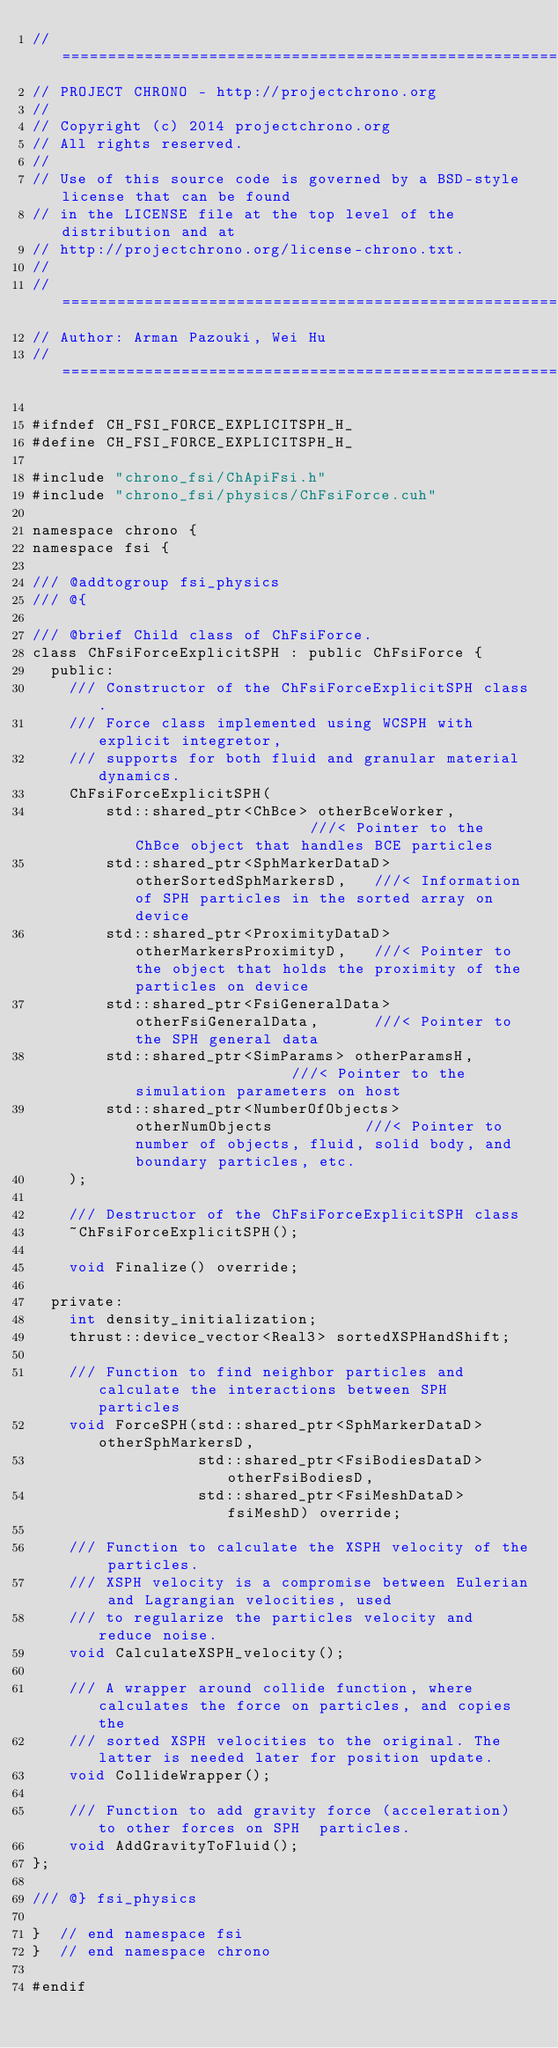<code> <loc_0><loc_0><loc_500><loc_500><_Cuda_>// =============================================================================
// PROJECT CHRONO - http://projectchrono.org
//
// Copyright (c) 2014 projectchrono.org
// All rights reserved.
//
// Use of this source code is governed by a BSD-style license that can be found
// in the LICENSE file at the top level of the distribution and at
// http://projectchrono.org/license-chrono.txt.
//
// =============================================================================
// Author: Arman Pazouki, Wei Hu
// =============================================================================

#ifndef CH_FSI_FORCE_EXPLICITSPH_H_
#define CH_FSI_FORCE_EXPLICITSPH_H_

#include "chrono_fsi/ChApiFsi.h"
#include "chrono_fsi/physics/ChFsiForce.cuh"

namespace chrono {
namespace fsi {

/// @addtogroup fsi_physics
/// @{

/// @brief Child class of ChFsiForce.
class ChFsiForceExplicitSPH : public ChFsiForce {
  public:
    /// Constructor of the ChFsiForceExplicitSPH class.
    /// Force class implemented using WCSPH with explicit integretor,
    /// supports for both fluid and granular material dynamics.
    ChFsiForceExplicitSPH(
        std::shared_ptr<ChBce> otherBceWorker,                    ///< Pointer to the ChBce object that handles BCE particles
        std::shared_ptr<SphMarkerDataD> otherSortedSphMarkersD,   ///< Information of SPH particles in the sorted array on device
        std::shared_ptr<ProximityDataD> otherMarkersProximityD,   ///< Pointer to the object that holds the proximity of the particles on device
        std::shared_ptr<FsiGeneralData> otherFsiGeneralData,      ///< Pointer to the SPH general data
        std::shared_ptr<SimParams> otherParamsH,                  ///< Pointer to the simulation parameters on host
        std::shared_ptr<NumberOfObjects> otherNumObjects          ///< Pointer to number of objects, fluid, solid body, and boundary particles, etc.
    );

    /// Destructor of the ChFsiForceExplicitSPH class
    ~ChFsiForceExplicitSPH();

    void Finalize() override;

  private:
    int density_initialization;
    thrust::device_vector<Real3> sortedXSPHandShift;

    /// Function to find neighbor particles and calculate the interactions between SPH particles
    void ForceSPH(std::shared_ptr<SphMarkerDataD> otherSphMarkersD,
                  std::shared_ptr<FsiBodiesDataD> otherFsiBodiesD,
                  std::shared_ptr<FsiMeshDataD> fsiMeshD) override;
    
    /// Function to calculate the XSPH velocity of the particles.
    /// XSPH velocity is a compromise between Eulerian and Lagrangian velocities, used
    /// to regularize the particles velocity and reduce noise.
    void CalculateXSPH_velocity();

    /// A wrapper around collide function, where calculates the force on particles, and copies the
    /// sorted XSPH velocities to the original. The latter is needed later for position update.
    void CollideWrapper();

    /// Function to add gravity force (acceleration) to other forces on SPH  particles.
    void AddGravityToFluid();
};

/// @} fsi_physics

}  // end namespace fsi
}  // end namespace chrono

#endif
</code> 